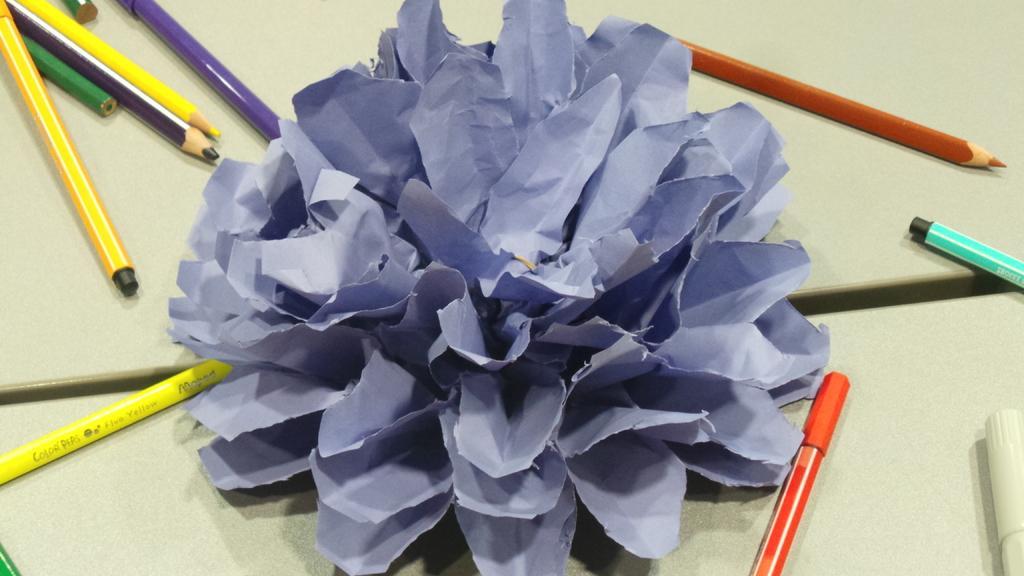In one or two sentences, can you explain what this image depicts? In the middle of the image we can see a paper craft, we can find pencils and pens on the table. 